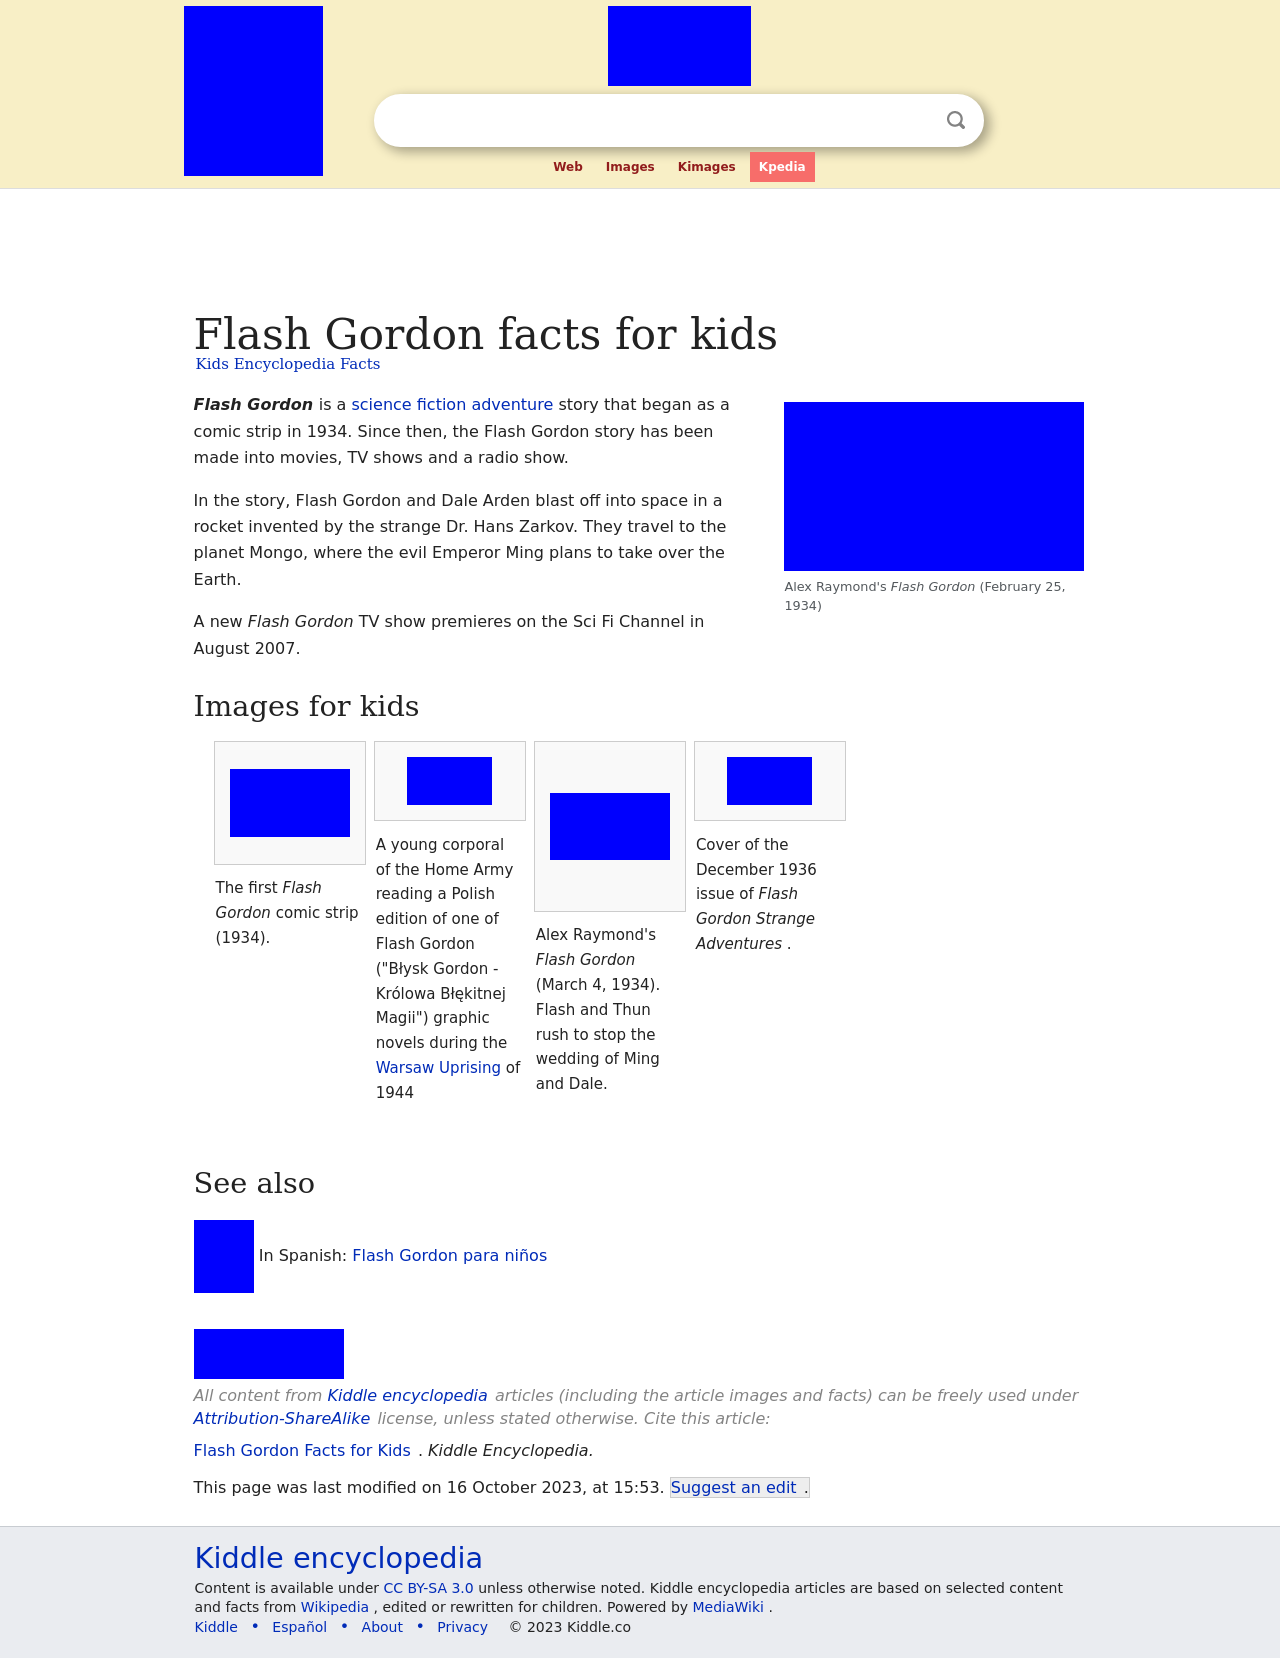What storylines are covered in the December 1936 issue of Flash Gordon Strange Adventures? The December 1936 issue of Flash Gordon Strange Adventures likely continued the ongoing sagas of Flash Gordon's battles against hostile forces within the universe of Mongo, alongside his companions. The stories typically involved high-stakes adventure, vivid extraterrestrial landscapes, and the thwarting of villainous schemes, likely focusing on the strategic battles and alliance-building crucial to the comic's plotlines. 